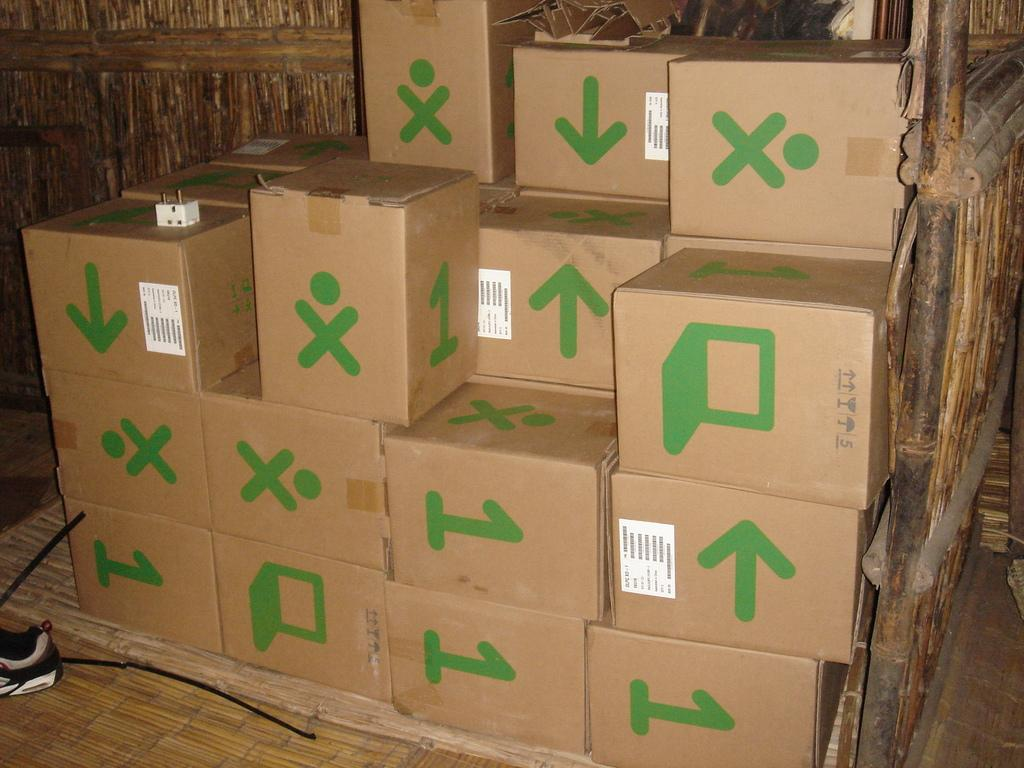<image>
Share a concise interpretation of the image provided. A stack of cardboard boxes that have ones and exes and arrows on them. 